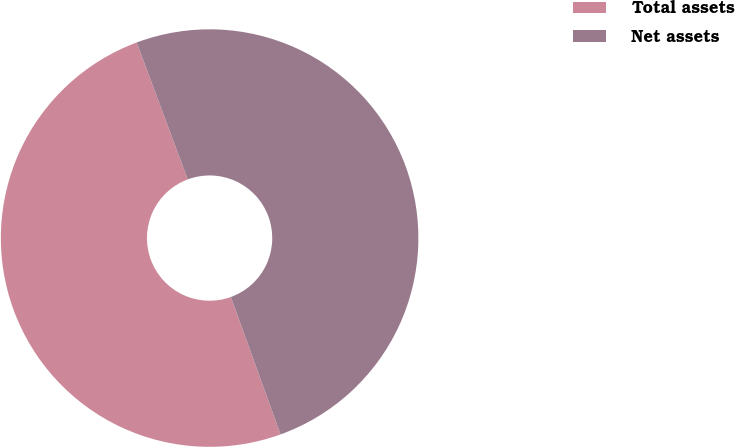<chart> <loc_0><loc_0><loc_500><loc_500><pie_chart><fcel>Total assets<fcel>Net assets<nl><fcel>49.84%<fcel>50.16%<nl></chart> 